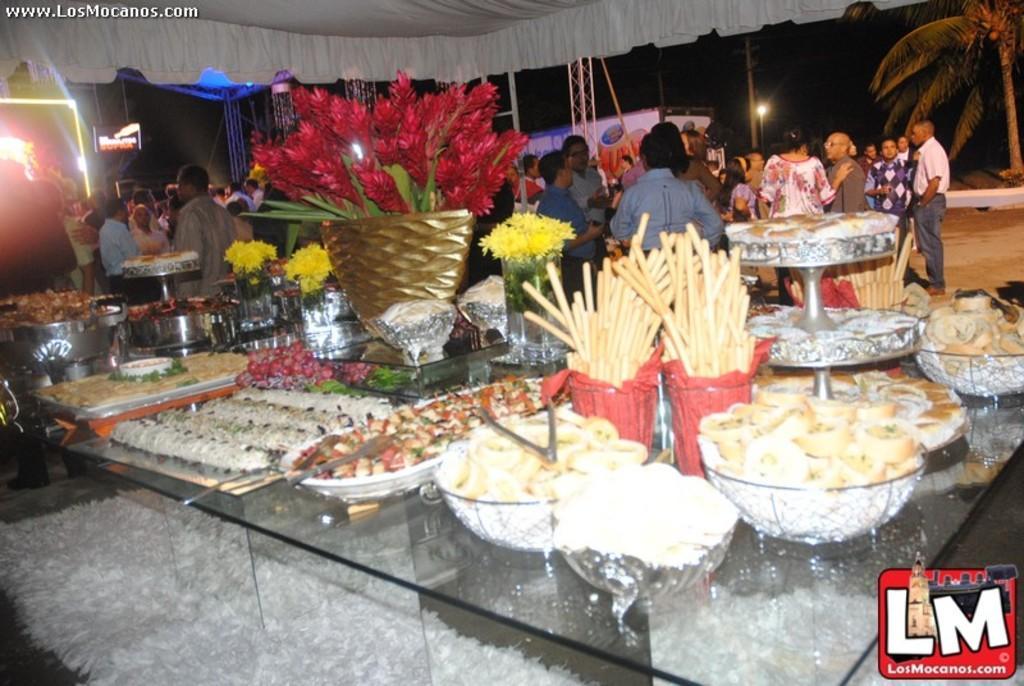Can you describe this image briefly? In this image I can see the glass table. On the table I can see many bowls and trays with food. To the side of these bowls I can see the flowers vases and the bouquets. These flowers are in yellow and red color. To the side few the table I can see the group of people standing. These people are wearing the different color dresses. In the background I can see the light, trees and the sky 